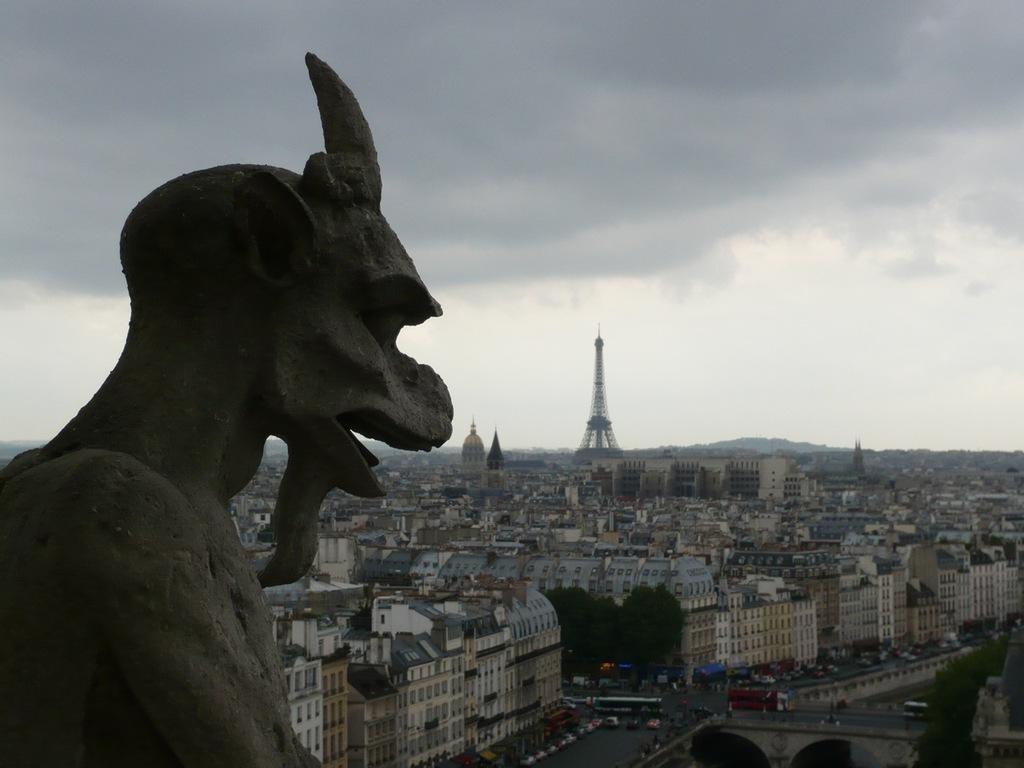In one or two sentences, can you explain what this image depicts? In the picture we can see a sculpture man with a horn and from the Ariel view we can see a city with buildings, roads and vehicles on it and tower and in the background we can see a sky with clouds. 